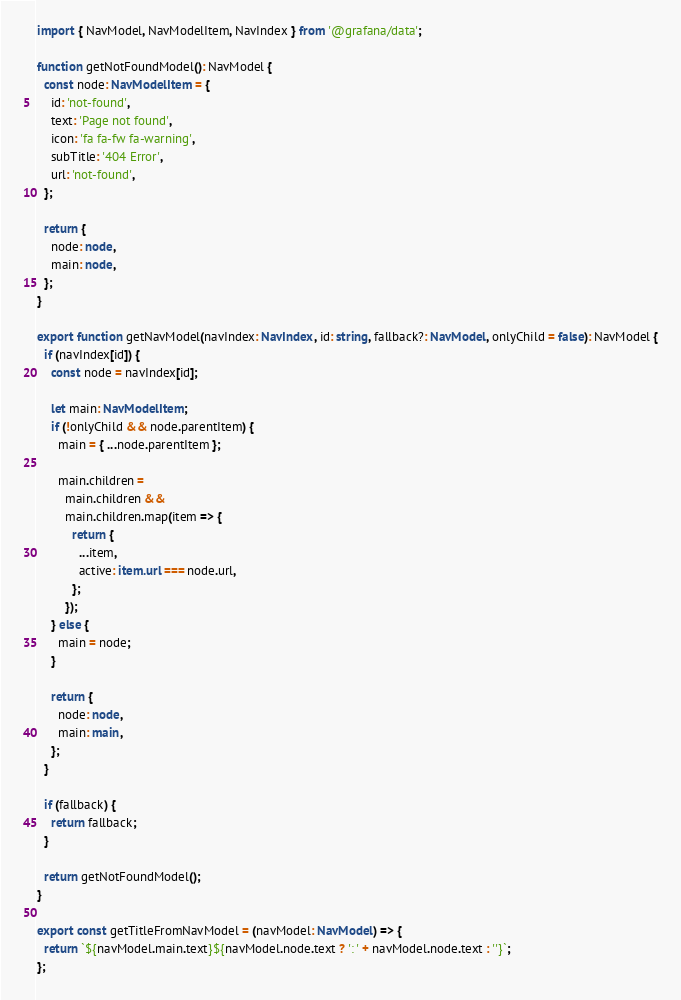<code> <loc_0><loc_0><loc_500><loc_500><_TypeScript_>import { NavModel, NavModelItem, NavIndex } from '@grafana/data';

function getNotFoundModel(): NavModel {
  const node: NavModelItem = {
    id: 'not-found',
    text: 'Page not found',
    icon: 'fa fa-fw fa-warning',
    subTitle: '404 Error',
    url: 'not-found',
  };

  return {
    node: node,
    main: node,
  };
}

export function getNavModel(navIndex: NavIndex, id: string, fallback?: NavModel, onlyChild = false): NavModel {
  if (navIndex[id]) {
    const node = navIndex[id];

    let main: NavModelItem;
    if (!onlyChild && node.parentItem) {
      main = { ...node.parentItem };

      main.children =
        main.children &&
        main.children.map(item => {
          return {
            ...item,
            active: item.url === node.url,
          };
        });
    } else {
      main = node;
    }

    return {
      node: node,
      main: main,
    };
  }

  if (fallback) {
    return fallback;
  }

  return getNotFoundModel();
}

export const getTitleFromNavModel = (navModel: NavModel) => {
  return `${navModel.main.text}${navModel.node.text ? ': ' + navModel.node.text : ''}`;
};
</code> 